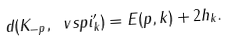Convert formula to latex. <formula><loc_0><loc_0><loc_500><loc_500>d ( K _ { - p } , \ v s p i _ { k } ^ { \prime } ) = E ( p , k ) + 2 h _ { k } .</formula> 